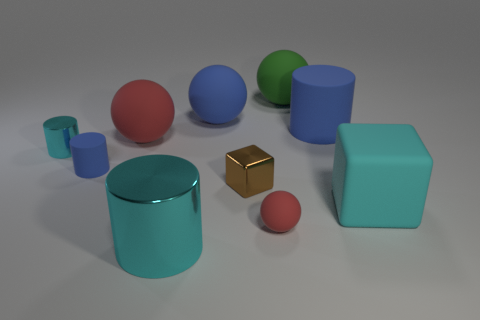How many balls have the same material as the big block?
Your answer should be compact. 4. Is the blue ball that is behind the big cyan metal thing made of the same material as the small blue thing?
Ensure brevity in your answer.  Yes. Are there more matte balls behind the brown metal block than cyan objects that are behind the big green rubber sphere?
Make the answer very short. Yes. What material is the green thing that is the same size as the blue sphere?
Offer a very short reply. Rubber. How many other objects are the same material as the small red sphere?
Provide a short and direct response. 6. There is a red thing that is behind the small cyan cylinder; does it have the same shape as the tiny metal object that is on the left side of the small blue object?
Give a very brief answer. No. What number of other objects are there of the same color as the small rubber cylinder?
Your answer should be very brief. 2. Do the big cylinder in front of the small cyan shiny thing and the cyan thing behind the brown cube have the same material?
Your answer should be very brief. Yes. Are there the same number of big cyan metallic objects behind the big green rubber object and spheres to the right of the blue matte sphere?
Offer a terse response. No. What is the red ball that is on the right side of the big cyan metallic cylinder made of?
Make the answer very short. Rubber. 